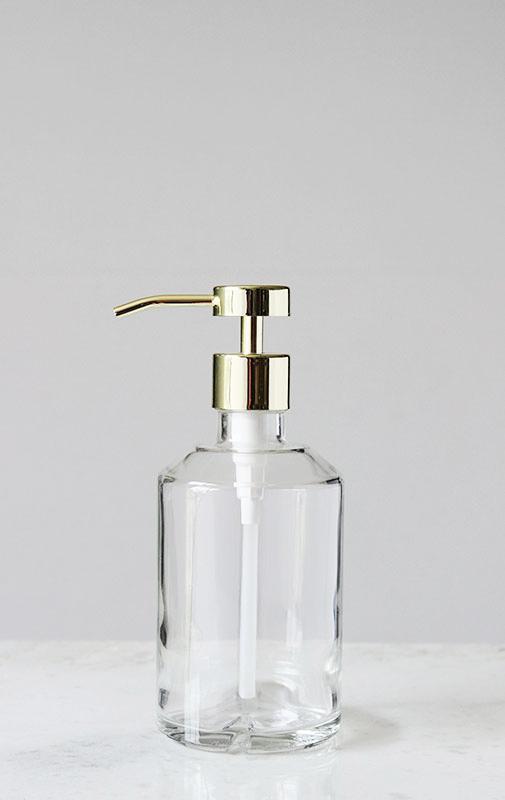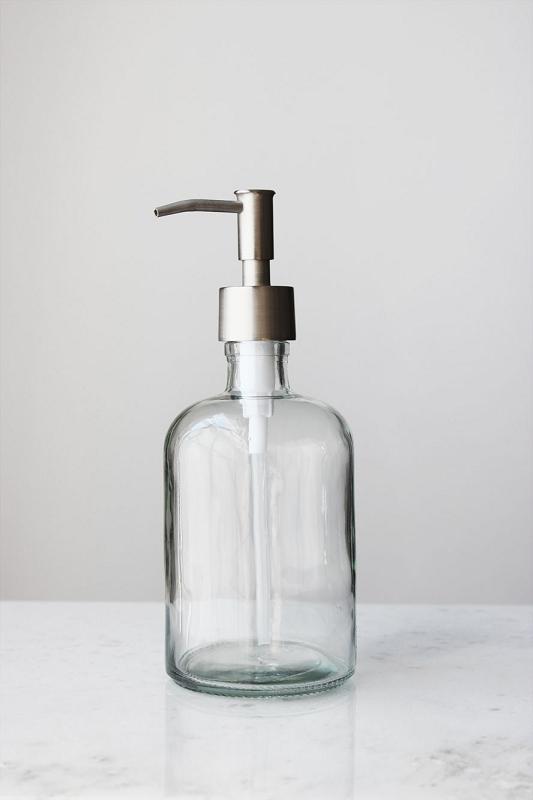The first image is the image on the left, the second image is the image on the right. Given the left and right images, does the statement "The dispenser in both pictures is pointing toward the left." hold true? Answer yes or no. Yes. The first image is the image on the left, the second image is the image on the right. For the images displayed, is the sentence "The right image is an empty soap dispenser facing to the right." factually correct? Answer yes or no. No. 